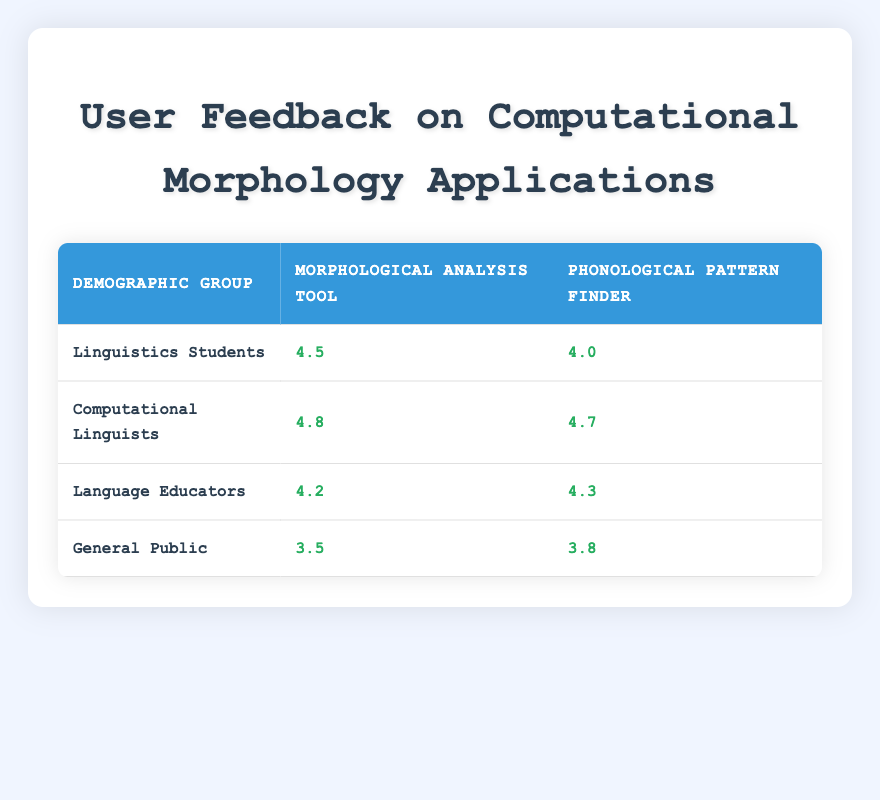What is the user feedback score for Linguistics Students using the Morphological Analysis Tool? According to the table, the user feedback score for Linguistics Students using the Morphological Analysis Tool is specifically listed in the corresponding cell. The score is 4.5.
Answer: 4.5 What is the average user feedback score for the Phonological Pattern Finder across all demographic groups? To find the average, we first sum the user feedback scores for the Phonological Pattern Finder: 4.0 (Linguistics Students) + 4.7 (Computational Linguists) + 4.3 (Language Educators) + 3.8 (General Public) = 16.8. Then, we divide by the number of groups, which is 4. So, the average is 16.8 / 4 = 4.2.
Answer: 4.2 Do Language Educators have a higher user feedback score for Morphological Analysis Tool than the General Public? Looking at the scores in the table, Language Educators have a score of 4.2, while the General Public scores 3.5 for the Morphological Analysis Tool. Since 4.2 is greater than 3.5, the statement is true.
Answer: Yes Which demographic group gave the highest score for the Phonological Pattern Finder? By comparing the scores for the Phonological Pattern Finder across all demographic groups, we see the scores listed are 4.0 (Linguistics Students), 4.7 (Computational Linguists), 4.3 (Language Educators), and 3.8 (General Public). The highest score is 4.7 from the Computational Linguists.
Answer: Computational Linguists What is the difference in user feedback scores between Linguistics Students and Language Educators for the Morphological Analysis Tool? The score for Linguistics Students for the Morphological Analysis Tool is 4.5, while for Language Educators it is 4.2. To find the difference, we subtract the two scores: 4.5 - 4.2 = 0.3.
Answer: 0.3 